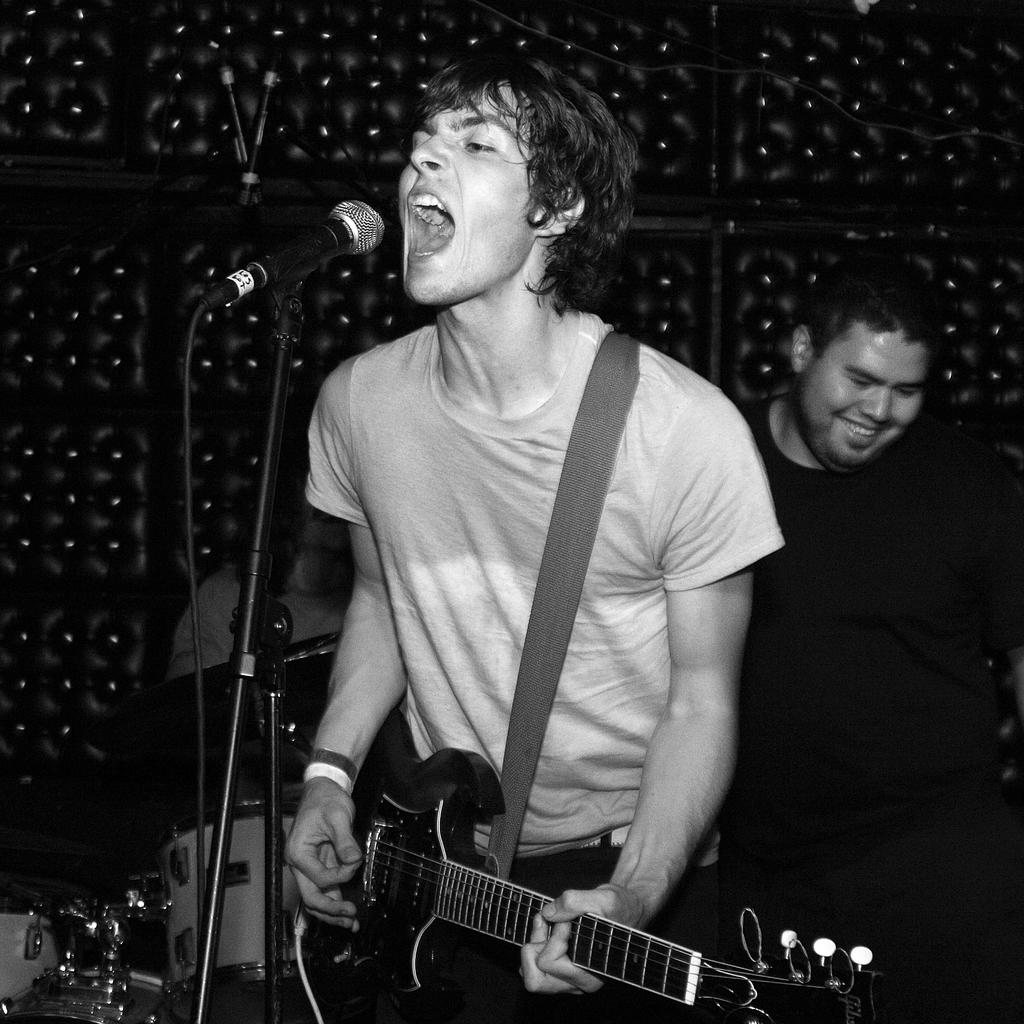What is the man in the image doing? The man is singing and playing a guitar. What is the man holding in his hand? The man is holding a microphone. How is the microphone positioned in the image? The microphone is on a stand. What other musical instrument can be seen in the image? There is a drum kit beside the man. What is the expression of the second man in the image? The second man is smiling. What can be observed about the background in the image? The background has several designs and lights. What type of territory is being claimed by the man with the guitar in the image? There is no indication of territory being claimed in the image; it features a man singing and playing a guitar. What activity is taking place during the recess in the image? There is no recess mentioned or depicted in the image. 